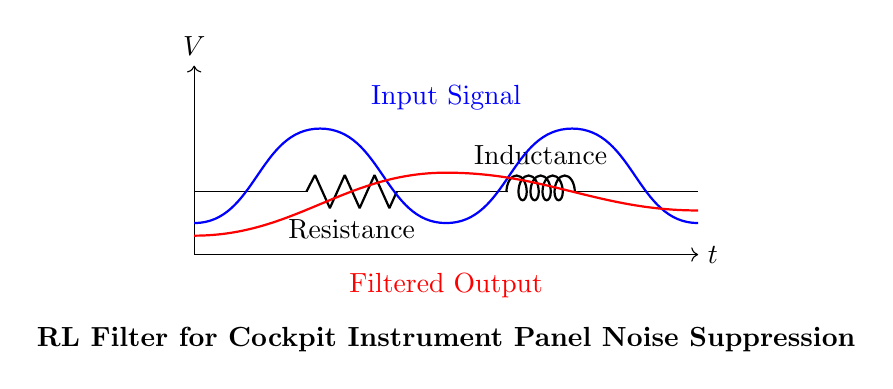What type of components are in this circuit? The circuit contains a resistor and an inductor, which are clearly labeled in the diagram. The component names can be identified by their symbols and the labels next to them.
Answer: Resistor, Inductor What is the purpose of the RL filter in this circuit? The purpose of the RL filter is to suppress noise from the cockpit instrument panel by allowing only specific frequency signals to pass through while attenuating unwanted noise. This is inferred from the filter's application context mentioned in the diagram.
Answer: Noise suppression What are the input and output signals labeled in the circuit? The input signal is represented by the thick blue line labeled "Input Signal," and the filtered output is the thick red line labeled "Filtered Output." The labels indicate the function of each signal in relation to the circuit.
Answer: Input Signal, Filtered Output What is the role of the resistance in this RL filter? The resistance controls the amount of current that can flow through the circuit, impacting the filter's frequency response and overall performance in suppressing unwanted noise. This can be deduced from the basic operation of resistors in filter circuits.
Answer: Current control How do resistance and inductance affect the cutoff frequency of this filter? The cutoff frequency of an RL filter depends on both the resistance and inductance values; it is calculated using the formula cut-off frequency equals resistance divided by inductance. The larger the resistance or inductance, the lower the cutoff frequency, meaning less high-frequency noise is allowed through.
Answer: They determine cutoff frequency What does the signal direction indicate in this circuit? The direction of the arrows indicates the flow of voltage and corresponds to how input signals are transformed into filtered outputs. The arrows show that the signal moves from the input towards the output, emphasizing the filter's effect.
Answer: Signal flow direction 